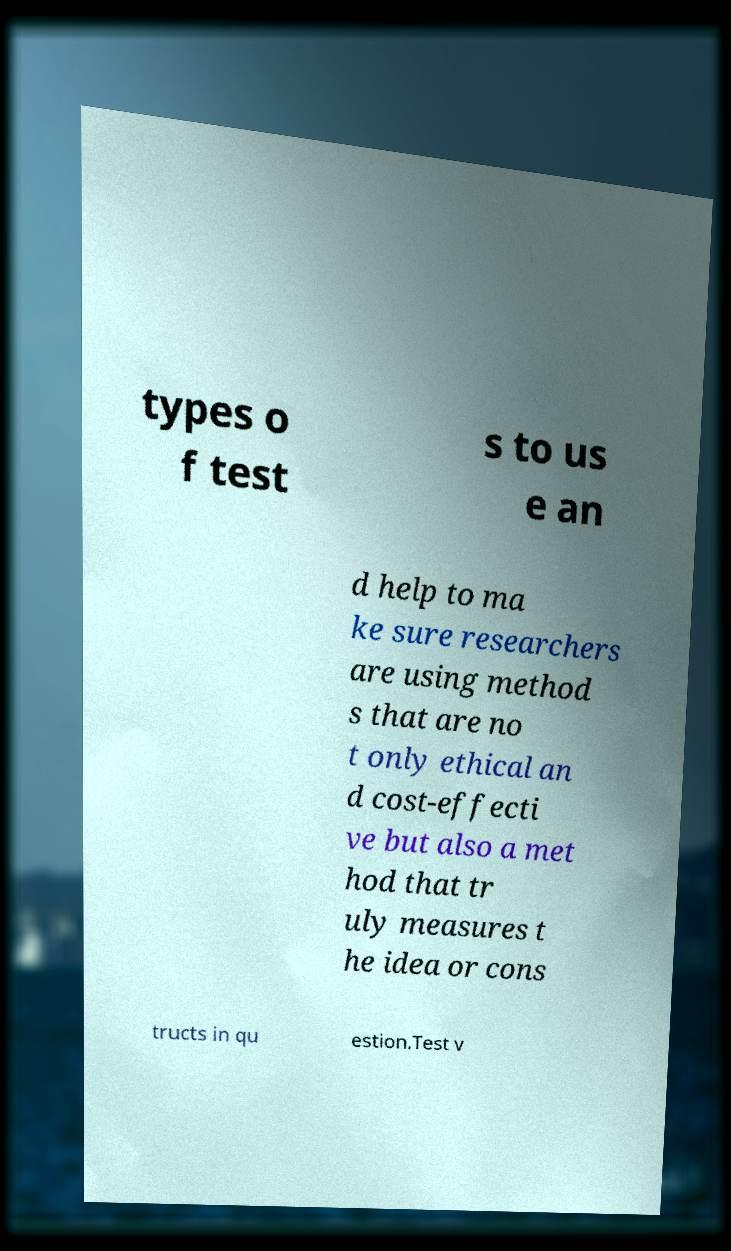For documentation purposes, I need the text within this image transcribed. Could you provide that? types o f test s to us e an d help to ma ke sure researchers are using method s that are no t only ethical an d cost-effecti ve but also a met hod that tr uly measures t he idea or cons tructs in qu estion.Test v 